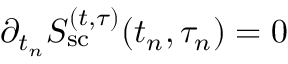Convert formula to latex. <formula><loc_0><loc_0><loc_500><loc_500>{ \partial _ { t _ { n } } S _ { s c } ^ { ( t , \tau ) } ( t _ { n } , \tau _ { n } ) } = 0</formula> 